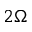Convert formula to latex. <formula><loc_0><loc_0><loc_500><loc_500>2 \Omega</formula> 